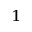<formula> <loc_0><loc_0><loc_500><loc_500>^ { 1 }</formula> 